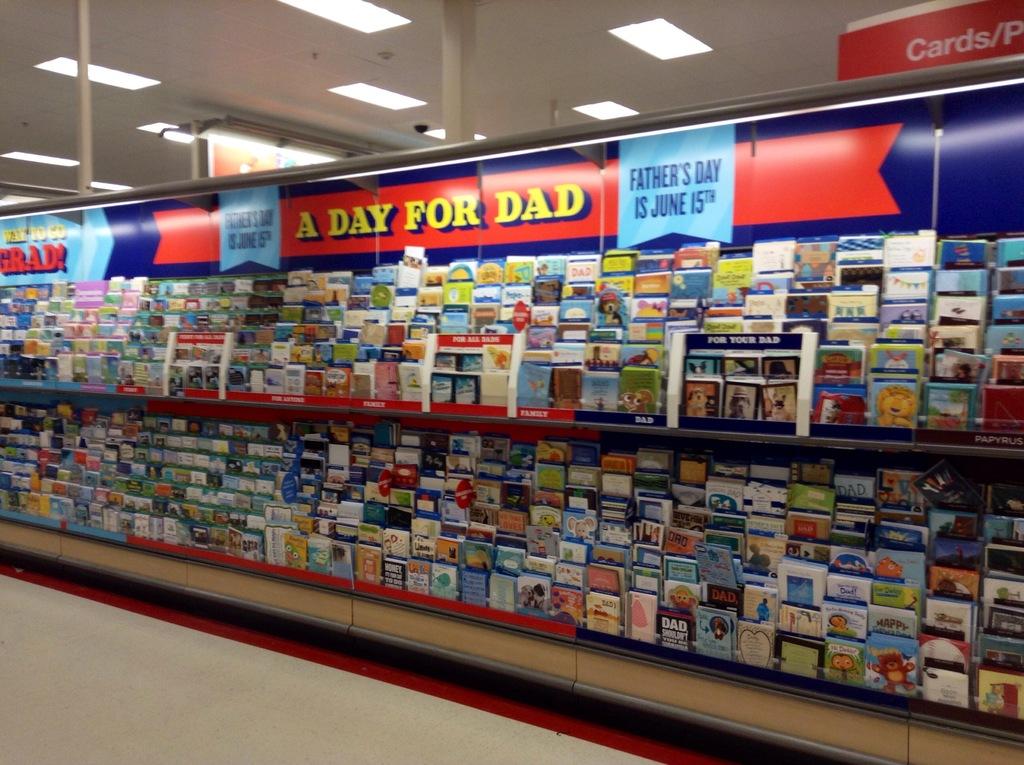What day is father's day?
Give a very brief answer. June 15th. What is it a day for?
Offer a terse response. Dad. 